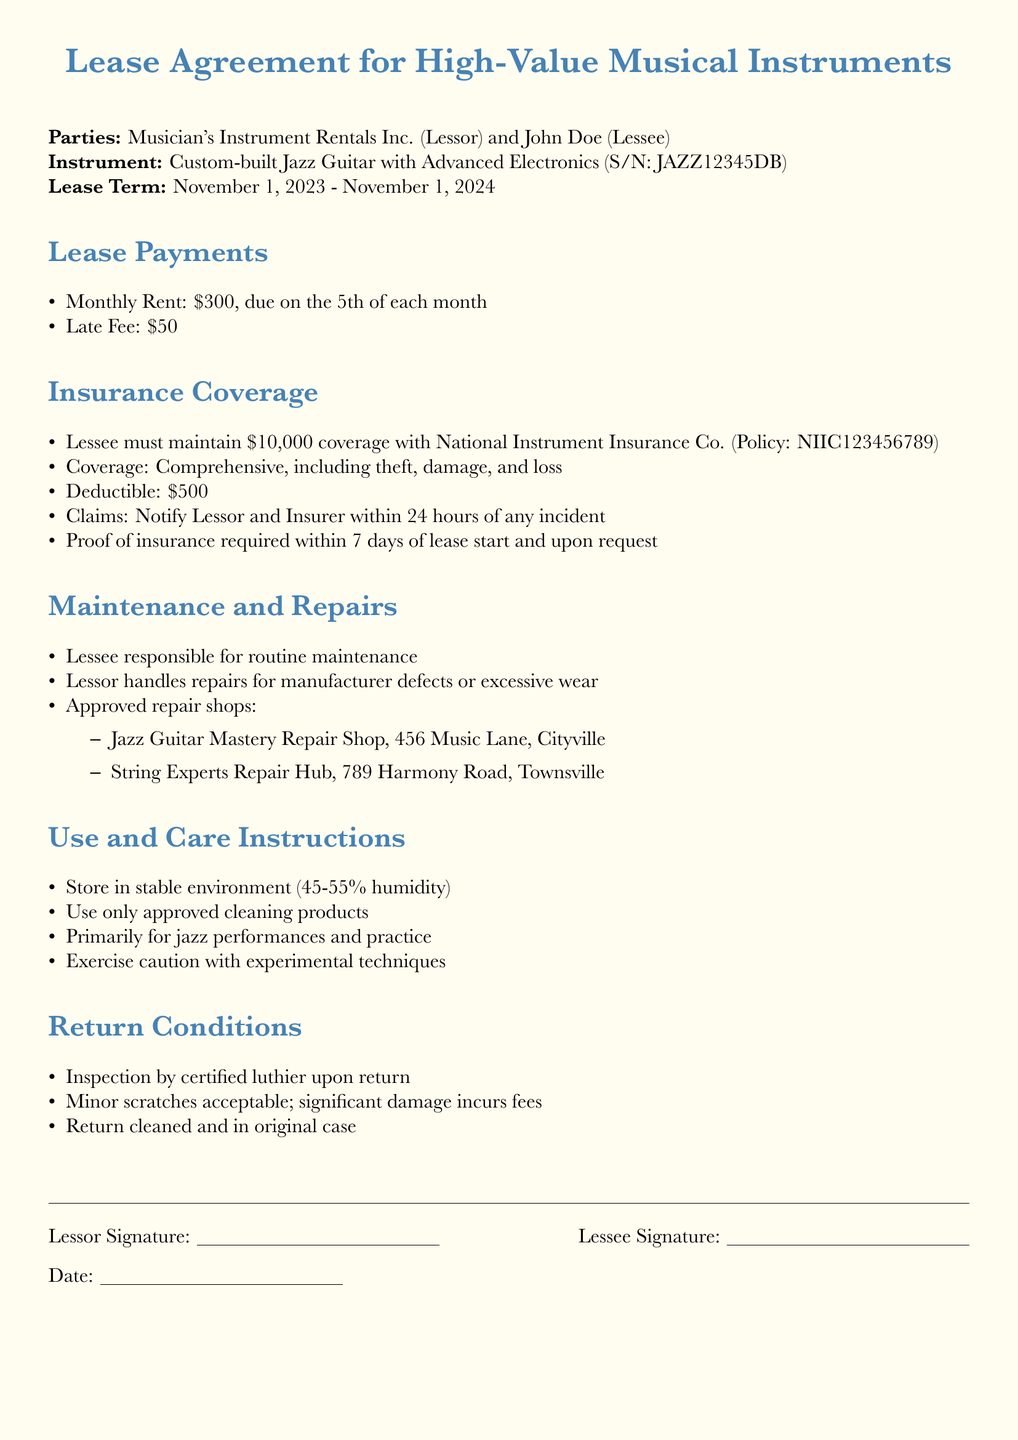What is the monthly rent for the lease? The monthly rent is stated in the Lease Payments section as $300.
Answer: $300 Who is the insurer for the instrument insurance? The insurer is mentioned in the Insurance Coverage section as National Instrument Insurance Co.
Answer: National Instrument Insurance Co What is the deductible amount? The deductible amount is specified in the Insurance Coverage section as $500.
Answer: $500 What is the lease term start date? The lease term start date is provided in the Lease Term section as November 1, 2023.
Answer: November 1, 2023 Is the Lessee responsible for routine maintenance? The Lease Agreement states in the Maintenance and Repairs section that the Lessee is responsible for routine maintenance.
Answer: Yes What type of coverage is required for the instrument? The type of coverage required is detailed in the Insurance Coverage section as Comprehensive.
Answer: Comprehensive What are the return conditions for the instrument? The return conditions are outlined in the Return Conditions section, including that the instrument must be inspected by a certified luthier.
Answer: Inspection by certified luthier What should the Lessee do within 24 hours of an incident? The document specifies in the Insurance Coverage section that the Lessee must notify the Lessor and Insurer within 24 hours of any incident.
Answer: Notify Lessor and Insurer What cleaning products should be used for the instrument? The Use and Care Instructions section states that only approved cleaning products should be used.
Answer: Approved cleaning products 